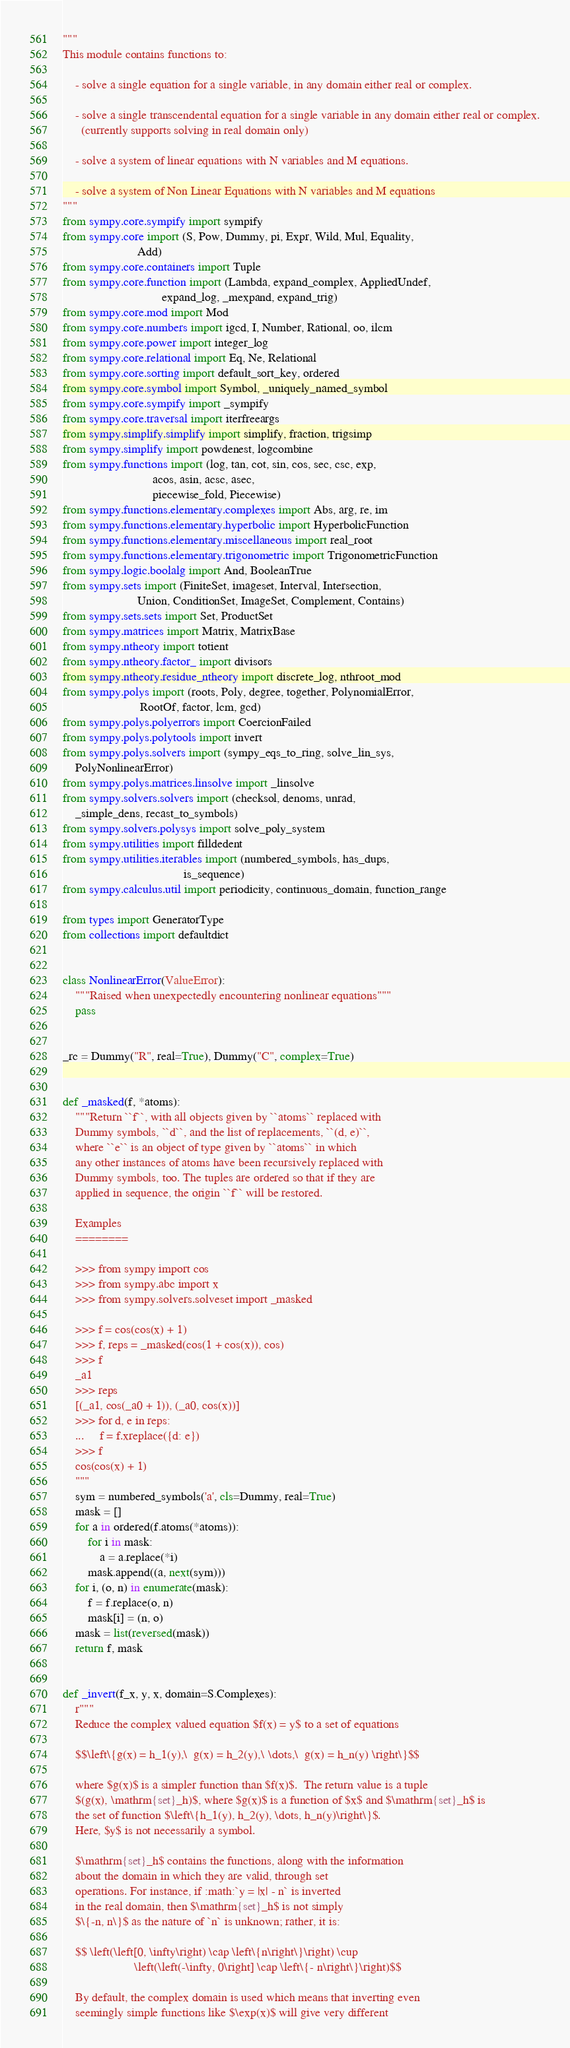Convert code to text. <code><loc_0><loc_0><loc_500><loc_500><_Python_>"""
This module contains functions to:

    - solve a single equation for a single variable, in any domain either real or complex.

    - solve a single transcendental equation for a single variable in any domain either real or complex.
      (currently supports solving in real domain only)

    - solve a system of linear equations with N variables and M equations.

    - solve a system of Non Linear Equations with N variables and M equations
"""
from sympy.core.sympify import sympify
from sympy.core import (S, Pow, Dummy, pi, Expr, Wild, Mul, Equality,
                        Add)
from sympy.core.containers import Tuple
from sympy.core.function import (Lambda, expand_complex, AppliedUndef,
                                expand_log, _mexpand, expand_trig)
from sympy.core.mod import Mod
from sympy.core.numbers import igcd, I, Number, Rational, oo, ilcm
from sympy.core.power import integer_log
from sympy.core.relational import Eq, Ne, Relational
from sympy.core.sorting import default_sort_key, ordered
from sympy.core.symbol import Symbol, _uniquely_named_symbol
from sympy.core.sympify import _sympify
from sympy.core.traversal import iterfreeargs
from sympy.simplify.simplify import simplify, fraction, trigsimp
from sympy.simplify import powdenest, logcombine
from sympy.functions import (log, tan, cot, sin, cos, sec, csc, exp,
                             acos, asin, acsc, asec,
                             piecewise_fold, Piecewise)
from sympy.functions.elementary.complexes import Abs, arg, re, im
from sympy.functions.elementary.hyperbolic import HyperbolicFunction
from sympy.functions.elementary.miscellaneous import real_root
from sympy.functions.elementary.trigonometric import TrigonometricFunction
from sympy.logic.boolalg import And, BooleanTrue
from sympy.sets import (FiniteSet, imageset, Interval, Intersection,
                        Union, ConditionSet, ImageSet, Complement, Contains)
from sympy.sets.sets import Set, ProductSet
from sympy.matrices import Matrix, MatrixBase
from sympy.ntheory import totient
from sympy.ntheory.factor_ import divisors
from sympy.ntheory.residue_ntheory import discrete_log, nthroot_mod
from sympy.polys import (roots, Poly, degree, together, PolynomialError,
                         RootOf, factor, lcm, gcd)
from sympy.polys.polyerrors import CoercionFailed
from sympy.polys.polytools import invert
from sympy.polys.solvers import (sympy_eqs_to_ring, solve_lin_sys,
    PolyNonlinearError)
from sympy.polys.matrices.linsolve import _linsolve
from sympy.solvers.solvers import (checksol, denoms, unrad,
    _simple_dens, recast_to_symbols)
from sympy.solvers.polysys import solve_poly_system
from sympy.utilities import filldedent
from sympy.utilities.iterables import (numbered_symbols, has_dups,
                                       is_sequence)
from sympy.calculus.util import periodicity, continuous_domain, function_range

from types import GeneratorType
from collections import defaultdict


class NonlinearError(ValueError):
    """Raised when unexpectedly encountering nonlinear equations"""
    pass


_rc = Dummy("R", real=True), Dummy("C", complex=True)


def _masked(f, *atoms):
    """Return ``f``, with all objects given by ``atoms`` replaced with
    Dummy symbols, ``d``, and the list of replacements, ``(d, e)``,
    where ``e`` is an object of type given by ``atoms`` in which
    any other instances of atoms have been recursively replaced with
    Dummy symbols, too. The tuples are ordered so that if they are
    applied in sequence, the origin ``f`` will be restored.

    Examples
    ========

    >>> from sympy import cos
    >>> from sympy.abc import x
    >>> from sympy.solvers.solveset import _masked

    >>> f = cos(cos(x) + 1)
    >>> f, reps = _masked(cos(1 + cos(x)), cos)
    >>> f
    _a1
    >>> reps
    [(_a1, cos(_a0 + 1)), (_a0, cos(x))]
    >>> for d, e in reps:
    ...     f = f.xreplace({d: e})
    >>> f
    cos(cos(x) + 1)
    """
    sym = numbered_symbols('a', cls=Dummy, real=True)
    mask = []
    for a in ordered(f.atoms(*atoms)):
        for i in mask:
            a = a.replace(*i)
        mask.append((a, next(sym)))
    for i, (o, n) in enumerate(mask):
        f = f.replace(o, n)
        mask[i] = (n, o)
    mask = list(reversed(mask))
    return f, mask


def _invert(f_x, y, x, domain=S.Complexes):
    r"""
    Reduce the complex valued equation $f(x) = y$ to a set of equations

    $$\left\{g(x) = h_1(y),\  g(x) = h_2(y),\ \dots,\  g(x) = h_n(y) \right\}$$

    where $g(x)$ is a simpler function than $f(x)$.  The return value is a tuple
    $(g(x), \mathrm{set}_h)$, where $g(x)$ is a function of $x$ and $\mathrm{set}_h$ is
    the set of function $\left\{h_1(y), h_2(y), \dots, h_n(y)\right\}$.
    Here, $y$ is not necessarily a symbol.

    $\mathrm{set}_h$ contains the functions, along with the information
    about the domain in which they are valid, through set
    operations. For instance, if :math:`y = |x| - n` is inverted
    in the real domain, then $\mathrm{set}_h$ is not simply
    $\{-n, n\}$ as the nature of `n` is unknown; rather, it is:

    $$ \left(\left[0, \infty\right) \cap \left\{n\right\}\right) \cup
                       \left(\left(-\infty, 0\right] \cap \left\{- n\right\}\right)$$

    By default, the complex domain is used which means that inverting even
    seemingly simple functions like $\exp(x)$ will give very different</code> 